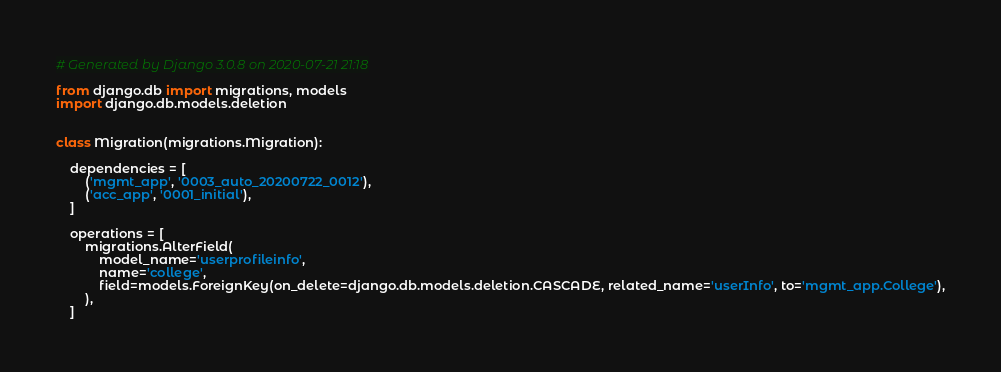Convert code to text. <code><loc_0><loc_0><loc_500><loc_500><_Python_># Generated by Django 3.0.8 on 2020-07-21 21:18

from django.db import migrations, models
import django.db.models.deletion


class Migration(migrations.Migration):

    dependencies = [
        ('mgmt_app', '0003_auto_20200722_0012'),
        ('acc_app', '0001_initial'),
    ]

    operations = [
        migrations.AlterField(
            model_name='userprofileinfo',
            name='college',
            field=models.ForeignKey(on_delete=django.db.models.deletion.CASCADE, related_name='userInfo', to='mgmt_app.College'),
        ),
    ]
</code> 